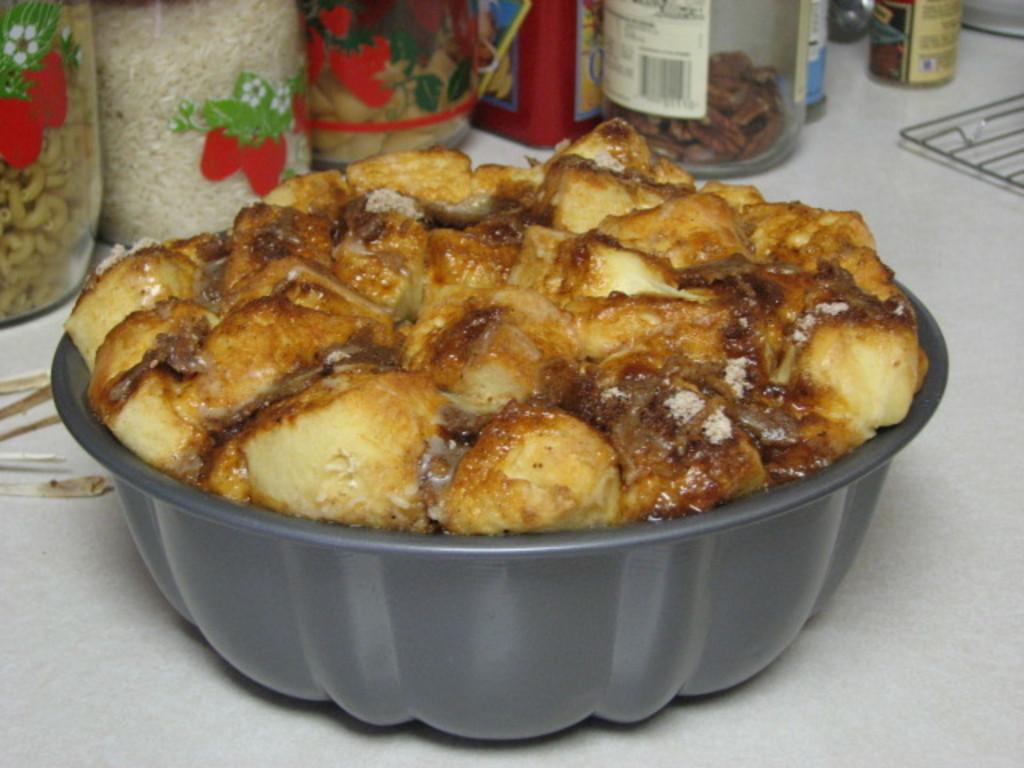Please provide a concise description of this image. In this image there is a table, on that table there is a bowl, in that bowl there is a food item, in the background there are bottles, in that bottle there is a food item. 